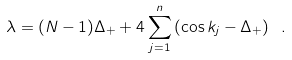<formula> <loc_0><loc_0><loc_500><loc_500>\lambda = ( N - 1 ) \Delta _ { + } + 4 \sum _ { j = 1 } ^ { n } \left ( \cos k _ { j } - \Delta _ { + } \right ) \ .</formula> 